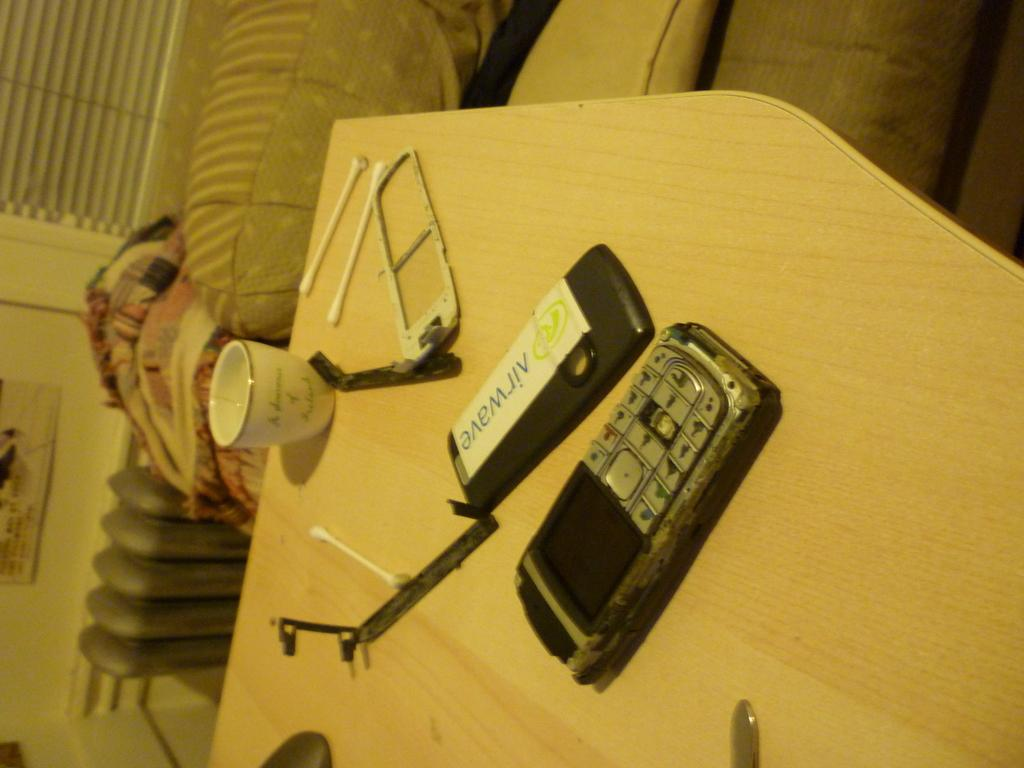Provide a one-sentence caption for the provided image. Broken cellphone next to a device that says "Airwave". 